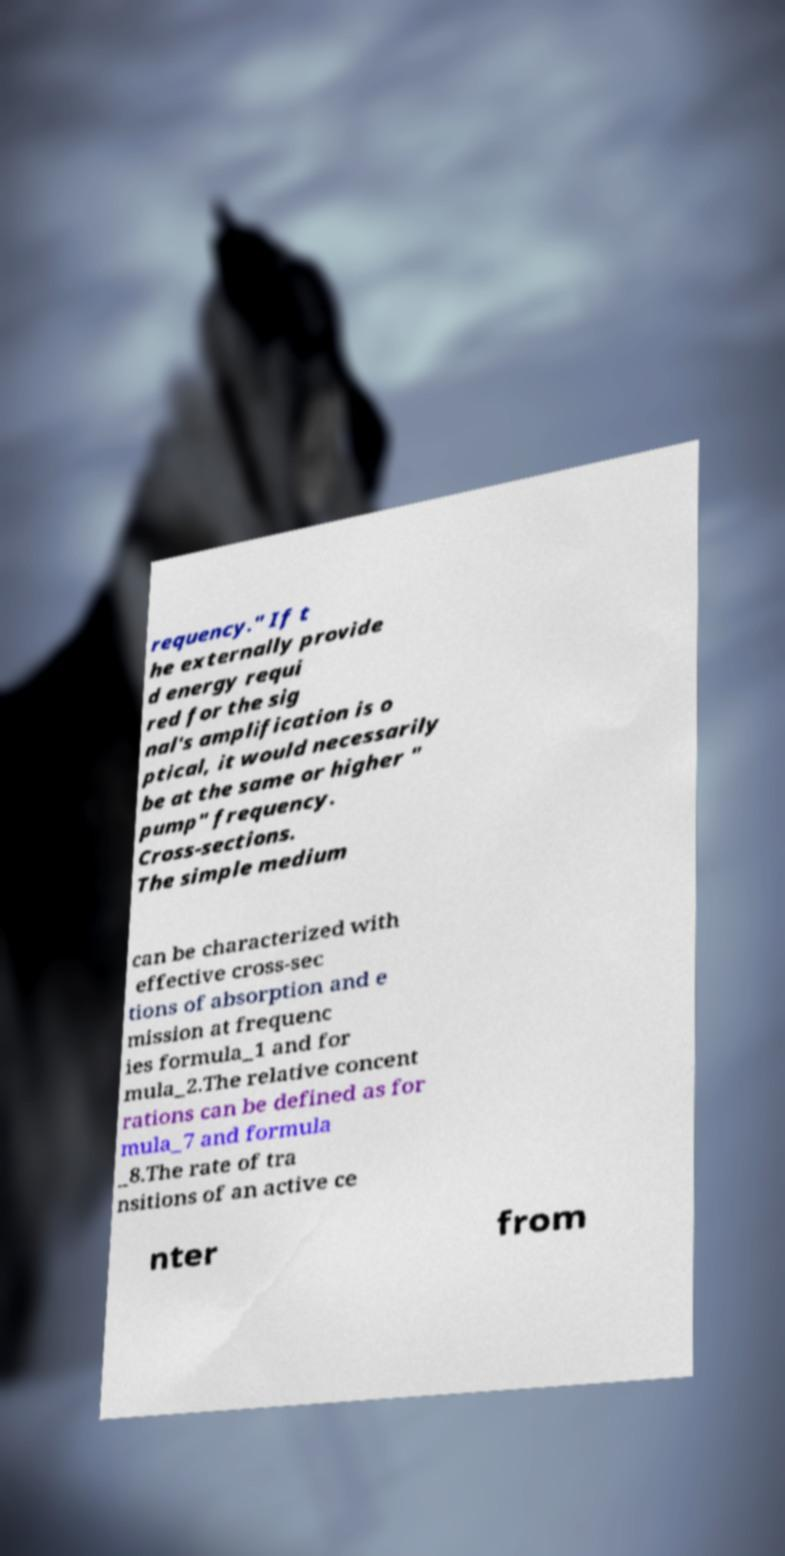Please identify and transcribe the text found in this image. requency." If t he externally provide d energy requi red for the sig nal's amplification is o ptical, it would necessarily be at the same or higher " pump" frequency. Cross-sections. The simple medium can be characterized with effective cross-sec tions of absorption and e mission at frequenc ies formula_1 and for mula_2.The relative concent rations can be defined as for mula_7 and formula _8.The rate of tra nsitions of an active ce nter from 